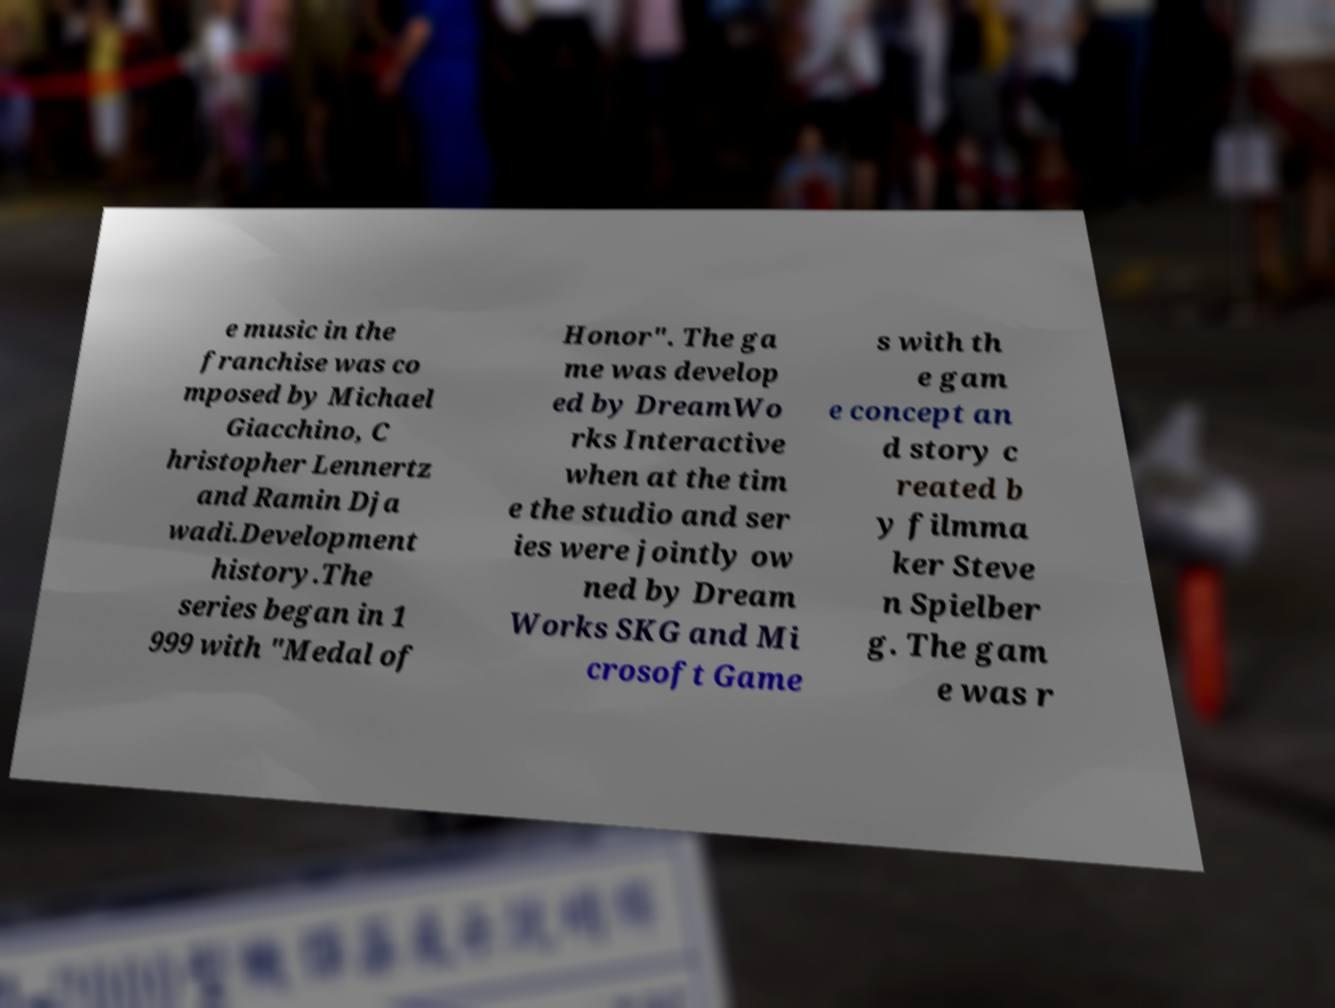Please identify and transcribe the text found in this image. e music in the franchise was co mposed by Michael Giacchino, C hristopher Lennertz and Ramin Dja wadi.Development history.The series began in 1 999 with "Medal of Honor". The ga me was develop ed by DreamWo rks Interactive when at the tim e the studio and ser ies were jointly ow ned by Dream Works SKG and Mi crosoft Game s with th e gam e concept an d story c reated b y filmma ker Steve n Spielber g. The gam e was r 